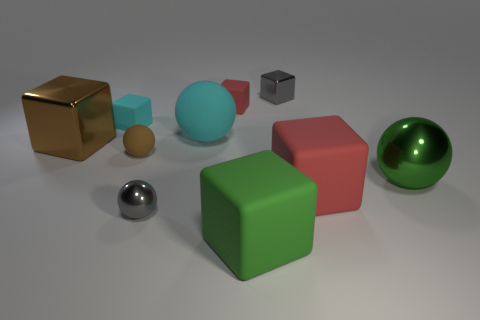There is a metal block to the left of the big cube that is in front of the tiny shiny sphere; what is its color?
Your answer should be compact. Brown. There is another rubber cube that is the same size as the cyan block; what is its color?
Give a very brief answer. Red. Are there any small metal cubes of the same color as the small metal sphere?
Provide a succinct answer. Yes. Are there any big green metallic objects?
Make the answer very short. Yes. There is a gray metallic thing that is in front of the large cyan rubber thing; what is its shape?
Keep it short and to the point. Sphere. How many small rubber things are both right of the tiny cyan cube and to the left of the big cyan matte ball?
Provide a short and direct response. 1. How many other objects are the same size as the green shiny object?
Your response must be concise. 4. Does the big metal object behind the brown ball have the same shape as the cyan thing that is to the left of the big matte sphere?
Make the answer very short. Yes. How many objects are gray cubes or rubber cubes that are behind the small brown matte ball?
Make the answer very short. 3. There is a big cube that is to the left of the big red rubber cube and right of the small gray ball; what material is it made of?
Provide a short and direct response. Rubber. 